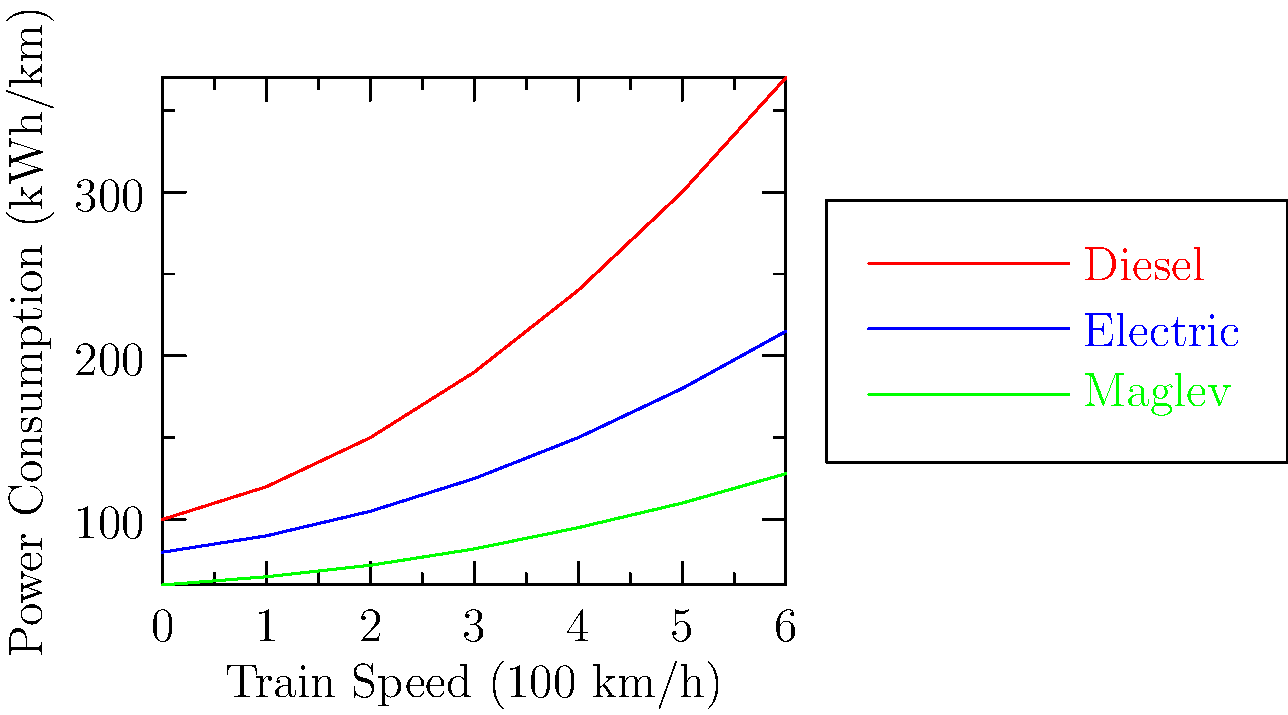Based on the power consumption graphs for different train propulsion systems, which system shows the best energy efficiency at higher speeds, and how might this impact our decision for upgrading the local railway system? To determine the most energy-efficient propulsion system at higher speeds, we need to analyze the power consumption trends as speed increases:

1. Diesel trains (red line):
   - Show the steepest increase in power consumption
   - At 600 km/h, consumption is approximately 370 kWh/km

2. Electric trains (blue line):
   - Show a moderate increase in power consumption
   - At 600 km/h, consumption is approximately 215 kWh/km

3. Maglev trains (green line):
   - Show the most gradual increase in power consumption
   - At 600 km/h, consumption is approximately 128 kWh/km

Comparing the three systems at higher speeds (right side of the graph):
- Maglev consumes the least power
- Electric trains consume more than Maglev but less than diesel
- Diesel trains consume the most power

The Maglev system demonstrates the best energy efficiency at higher speeds. This efficiency could lead to:
1. Lower operational costs
2. Reduced environmental impact
3. Potential for higher speeds without excessive energy consumption

When considering upgrading the local railway system, the Maglev technology offers the best energy efficiency. However, other factors should also be considered:
- Initial infrastructure costs
- Compatibility with existing systems
- Maintenance requirements
- Local terrain and weather conditions

The decision should balance long-term energy efficiency with these other important factors.
Answer: Maglev shows the best energy efficiency at higher speeds, potentially offering lower operational costs and reduced environmental impact for long-term railway system upgrades. 